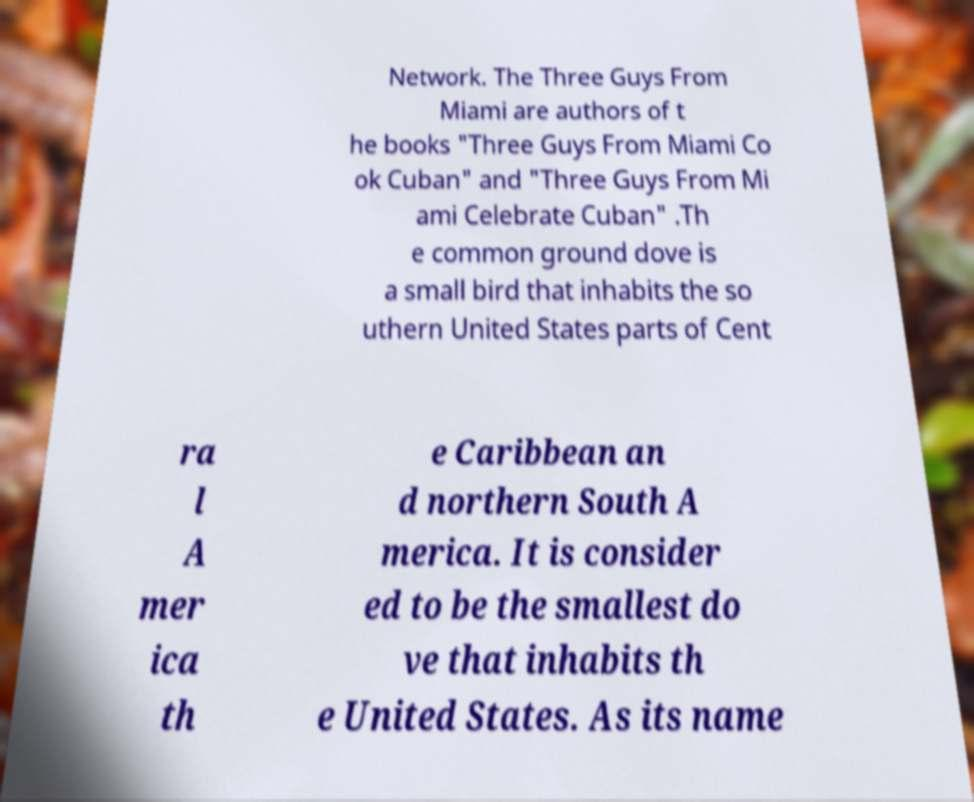Can you accurately transcribe the text from the provided image for me? Network. The Three Guys From Miami are authors of t he books "Three Guys From Miami Co ok Cuban" and "Three Guys From Mi ami Celebrate Cuban" .Th e common ground dove is a small bird that inhabits the so uthern United States parts of Cent ra l A mer ica th e Caribbean an d northern South A merica. It is consider ed to be the smallest do ve that inhabits th e United States. As its name 